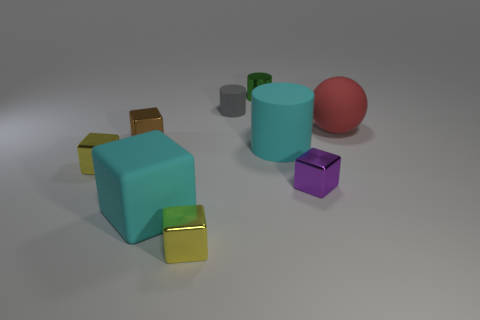Subtract 1 cubes. How many cubes are left? 4 Subtract all blue cylinders. Subtract all yellow cubes. How many cylinders are left? 3 Add 1 large red objects. How many objects exist? 10 Subtract all balls. How many objects are left? 8 Add 9 large matte cubes. How many large matte cubes are left? 10 Add 8 tiny brown blocks. How many tiny brown blocks exist? 9 Subtract 0 cyan balls. How many objects are left? 9 Subtract all metal objects. Subtract all tiny gray things. How many objects are left? 3 